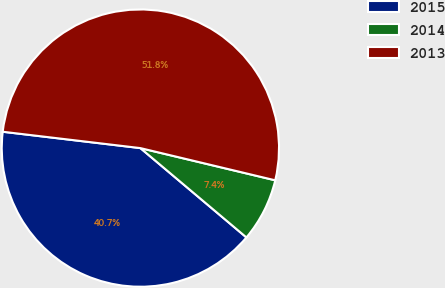Convert chart to OTSL. <chart><loc_0><loc_0><loc_500><loc_500><pie_chart><fcel>2015<fcel>2014<fcel>2013<nl><fcel>40.74%<fcel>7.41%<fcel>51.85%<nl></chart> 